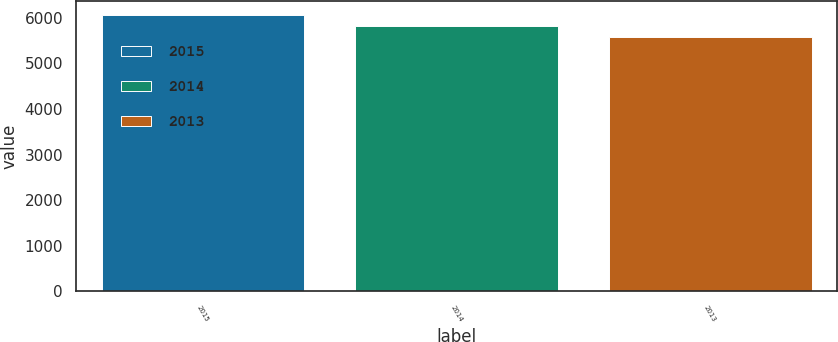Convert chart. <chart><loc_0><loc_0><loc_500><loc_500><bar_chart><fcel>2015<fcel>2014<fcel>2013<nl><fcel>6063<fcel>5824<fcel>5574<nl></chart> 